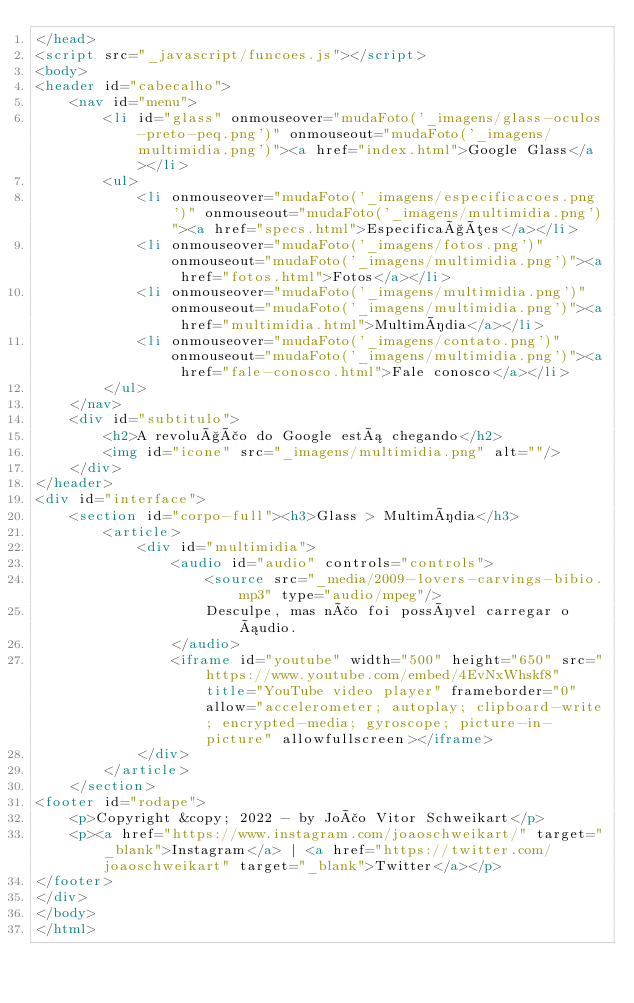Convert code to text. <code><loc_0><loc_0><loc_500><loc_500><_HTML_></head>
<script src="_javascript/funcoes.js"></script>
<body>
<header id="cabecalho">
    <nav id="menu">
        <li id="glass" onmouseover="mudaFoto('_imagens/glass-oculos-preto-peq.png')" onmouseout="mudaFoto('_imagens/multimidia.png')"><a href="index.html">Google Glass</a></li>
        <ul>
            <li onmouseover="mudaFoto('_imagens/especificacoes.png')" onmouseout="mudaFoto('_imagens/multimidia.png')"><a href="specs.html">Especificações</a></li>
            <li onmouseover="mudaFoto('_imagens/fotos.png')" onmouseout="mudaFoto('_imagens/multimidia.png')"><a href="fotos.html">Fotos</a></li>
            <li onmouseover="mudaFoto('_imagens/multimidia.png')" onmouseout="mudaFoto('_imagens/multimidia.png')"><a href="multimidia.html">Multimídia</a></li>
            <li onmouseover="mudaFoto('_imagens/contato.png')" onmouseout="mudaFoto('_imagens/multimidia.png')"><a href="fale-conosco.html">Fale conosco</a></li>
        </ul>
    </nav>
    <div id="subtitulo">
        <h2>A revolução do Google está chegando</h2>
        <img id="icone" src="_imagens/multimidia.png" alt=""/>
    </div>
</header>
<div id="interface">
    <section id="corpo-full"><h3>Glass > Multimídia</h3>
        <article>
            <div id="multimidia">
                <audio id="audio" controls="controls">
                    <source src="_media/2009-lovers-carvings-bibio.mp3" type="audio/mpeg"/>
                    Desculpe, mas não foi possível carregar o áudio.
                </audio>
                <iframe id="youtube" width="500" height="650" src="https://www.youtube.com/embed/4EvNxWhskf8" title="YouTube video player" frameborder="0" allow="accelerometer; autoplay; clipboard-write; encrypted-media; gyroscope; picture-in-picture" allowfullscreen></iframe>
            </div>
        </article>
    </section>
<footer id="rodape">
    <p>Copyright &copy; 2022 - by João Vitor Schweikart</p>
    <p><a href="https://www.instagram.com/joaoschweikart/" target="_blank">Instagram</a> | <a href="https://twitter.com/joaoschweikart" target="_blank">Twitter</a></p>
</footer>
</div>
</body>
</html>
</code> 